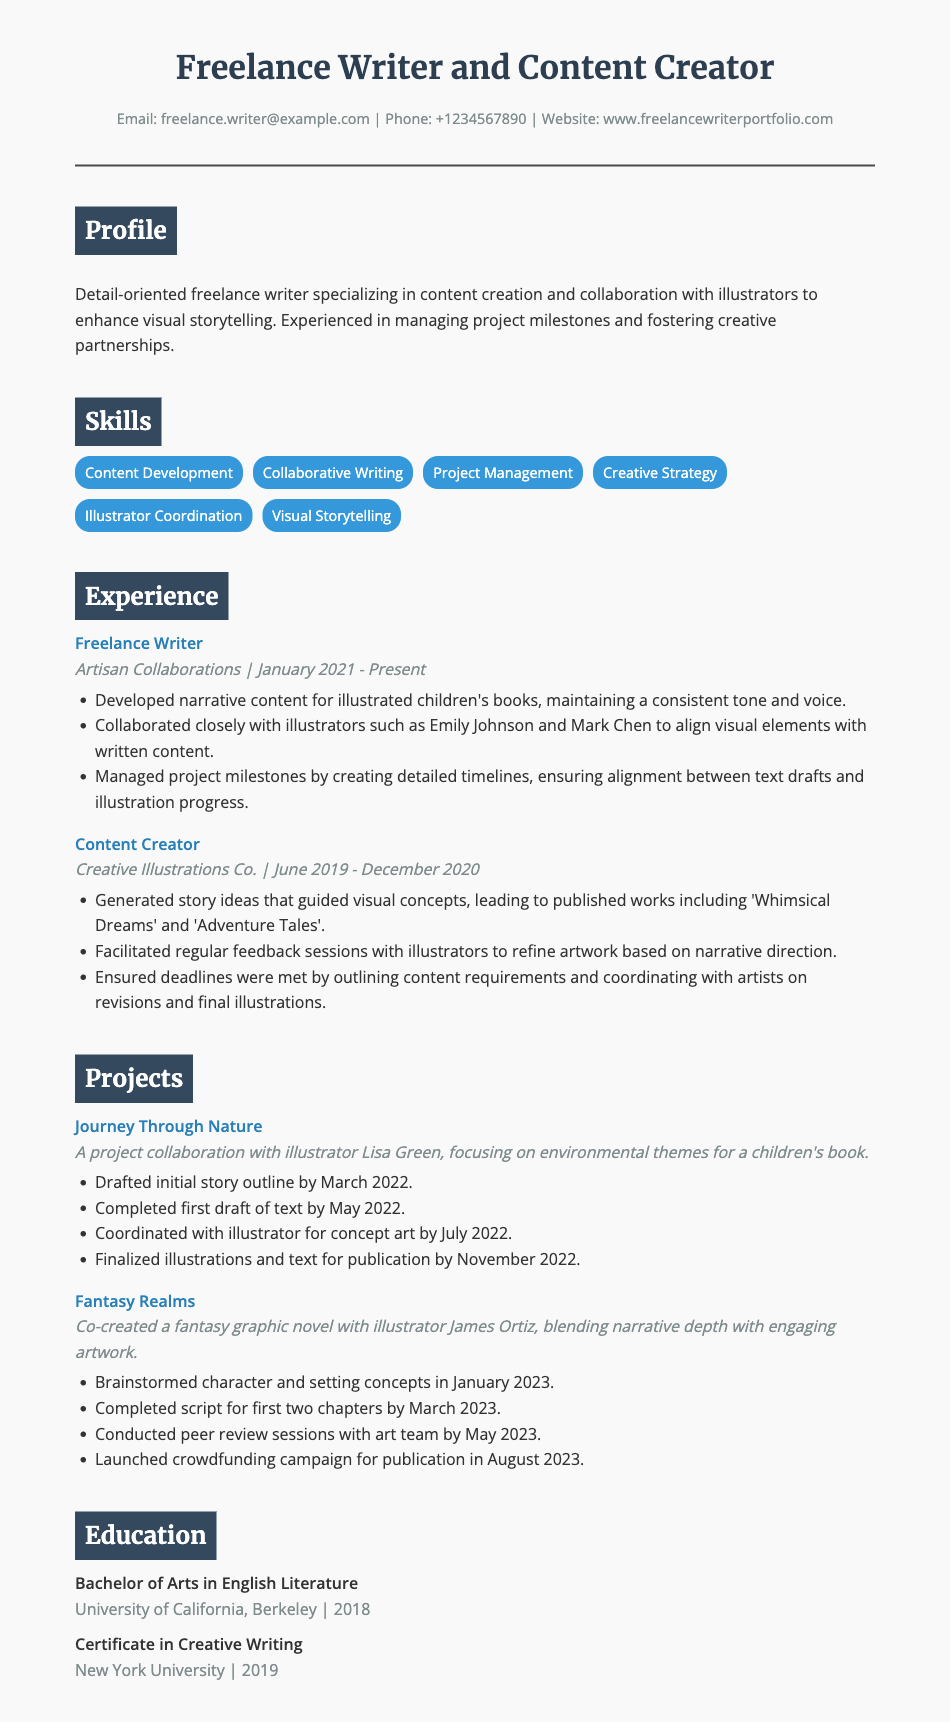what is the name of the freelance writer? The document lists the freelance writer's name in the header, which is "Freelance Writer and Content Creator."
Answer: Freelance Writer and Content Creator what is the email address provided in the contact info? The contact information contains the email address which is "freelance.writer@example.com."
Answer: freelance.writer@example.com which company did the freelance writer work for as a Content Creator? The resume specifies the company name associated with the Content Creator role, which is "Creative Illustrations Co."
Answer: Creative Illustrations Co when did the freelance writer start working as a Freelance Writer? The timeline provided in the experience section indicates the start date is "January 2021."
Answer: January 2021 who is the illustrator collaborated with on the project "Journey Through Nature"? The document mentions the illustrator's name involved in this project as "Lisa Green."
Answer: Lisa Green how many projects are listed in the Projects section? The document outlines two separate projects in the Projects section, which can be counted.
Answer: 2 what degree did the freelance writer obtain in 2018? The education section specifies the degree acquired in 2018, which is "Bachelor of Arts in English Literature."
Answer: Bachelor of Arts in English Literature what skill is specifically mentioned for coordinating with illustrators? The skills section includes a specific skill for working with illustrators, namely "Illustrator Coordination."
Answer: Illustrator Coordination which project was launched with a crowdfunding campaign? The projects listed include one that mentions a crowdfunding campaign, identified as "Fantasy Realms."
Answer: Fantasy Realms 